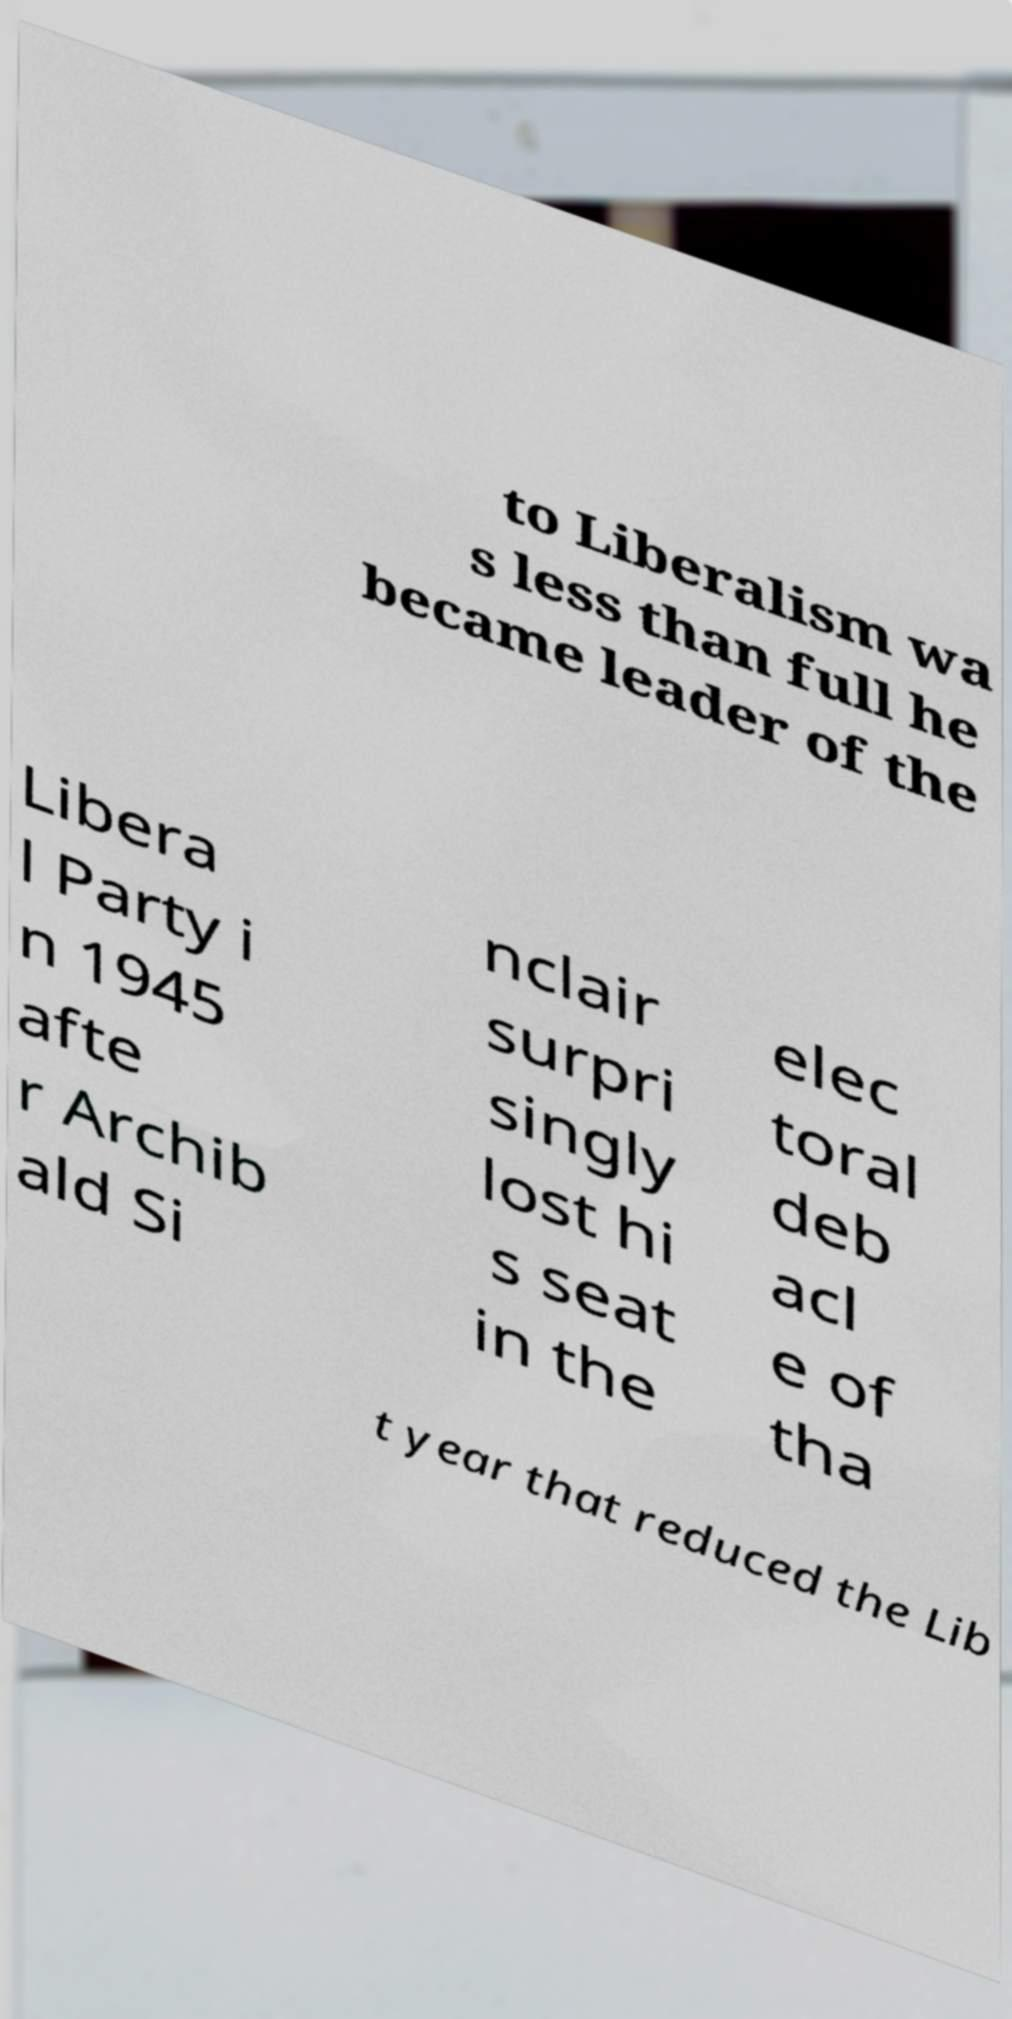Please identify and transcribe the text found in this image. to Liberalism wa s less than full he became leader of the Libera l Party i n 1945 afte r Archib ald Si nclair surpri singly lost hi s seat in the elec toral deb acl e of tha t year that reduced the Lib 